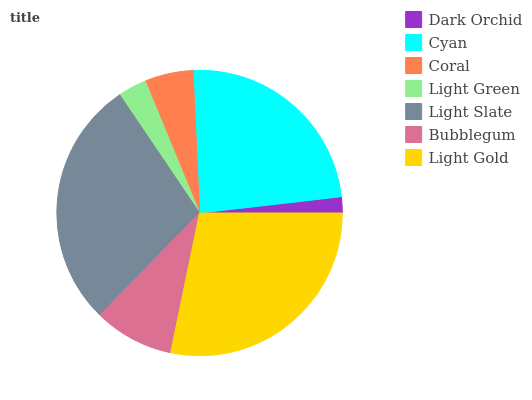Is Dark Orchid the minimum?
Answer yes or no. Yes. Is Light Gold the maximum?
Answer yes or no. Yes. Is Cyan the minimum?
Answer yes or no. No. Is Cyan the maximum?
Answer yes or no. No. Is Cyan greater than Dark Orchid?
Answer yes or no. Yes. Is Dark Orchid less than Cyan?
Answer yes or no. Yes. Is Dark Orchid greater than Cyan?
Answer yes or no. No. Is Cyan less than Dark Orchid?
Answer yes or no. No. Is Bubblegum the high median?
Answer yes or no. Yes. Is Bubblegum the low median?
Answer yes or no. Yes. Is Coral the high median?
Answer yes or no. No. Is Coral the low median?
Answer yes or no. No. 